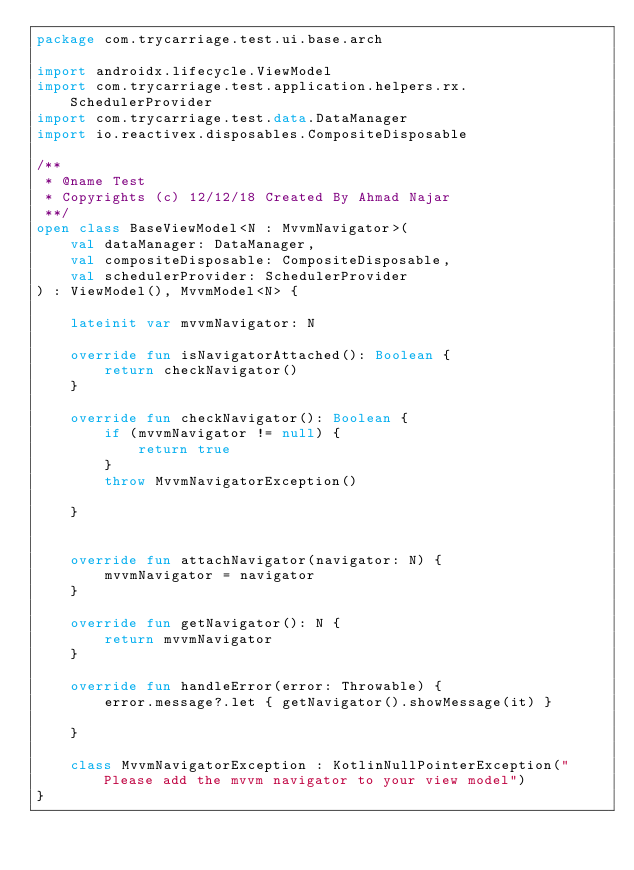<code> <loc_0><loc_0><loc_500><loc_500><_Kotlin_>package com.trycarriage.test.ui.base.arch

import androidx.lifecycle.ViewModel
import com.trycarriage.test.application.helpers.rx.SchedulerProvider
import com.trycarriage.test.data.DataManager
import io.reactivex.disposables.CompositeDisposable

/**
 * @name Test
 * Copyrights (c) 12/12/18 Created By Ahmad Najar
 **/
open class BaseViewModel<N : MvvmNavigator>(
    val dataManager: DataManager,
    val compositeDisposable: CompositeDisposable,
    val schedulerProvider: SchedulerProvider
) : ViewModel(), MvvmModel<N> {

    lateinit var mvvmNavigator: N

    override fun isNavigatorAttached(): Boolean {
        return checkNavigator()
    }

    override fun checkNavigator(): Boolean {
        if (mvvmNavigator != null) {
            return true
        }
        throw MvvmNavigatorException()

    }


    override fun attachNavigator(navigator: N) {
        mvvmNavigator = navigator
    }

    override fun getNavigator(): N {
        return mvvmNavigator
    }

    override fun handleError(error: Throwable) {
        error.message?.let { getNavigator().showMessage(it) }

    }

    class MvvmNavigatorException : KotlinNullPointerException("Please add the mvvm navigator to your view model")
}</code> 